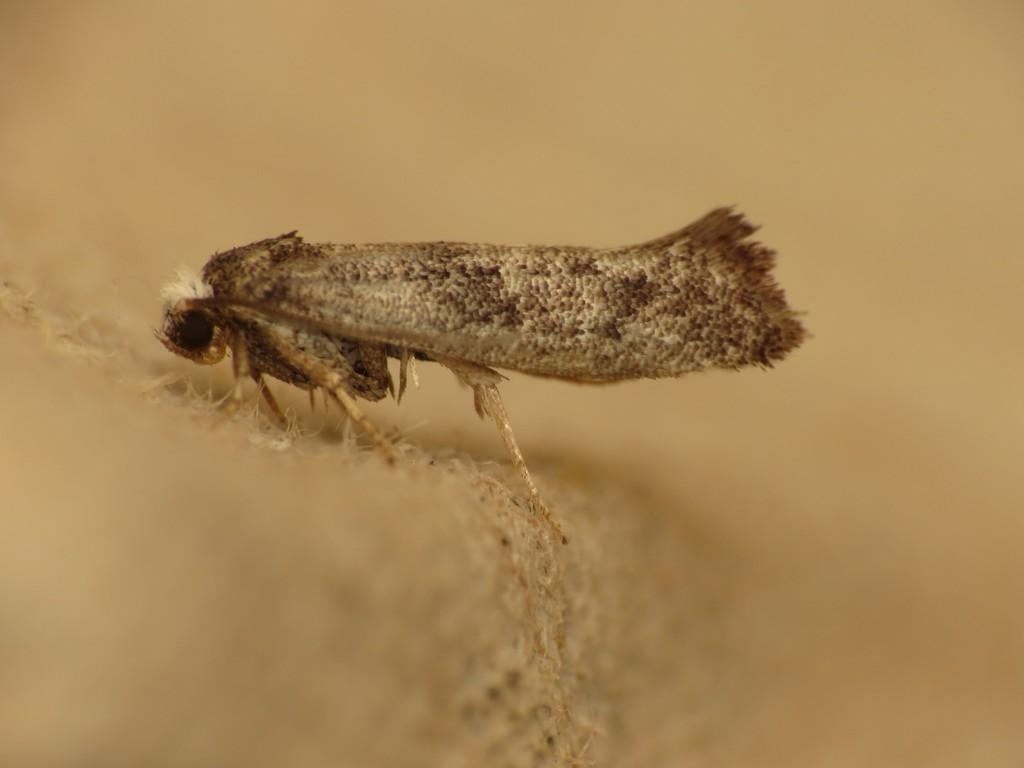What type of creature is in the image? There is a cream-colored insect in the image. Can you describe the quality of the background in the image? The image is blurry in the background. What type of shoe can be seen in the image? There is no shoe present in the image; it features a cream-colored insect. What wish can be granted by looking at the image? There is no wish-granting element in the image; it simply shows a cream-colored insect and a blurry background. 